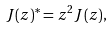Convert formula to latex. <formula><loc_0><loc_0><loc_500><loc_500>J ( z ) ^ { * } = z ^ { 2 } J ( z ) ,</formula> 